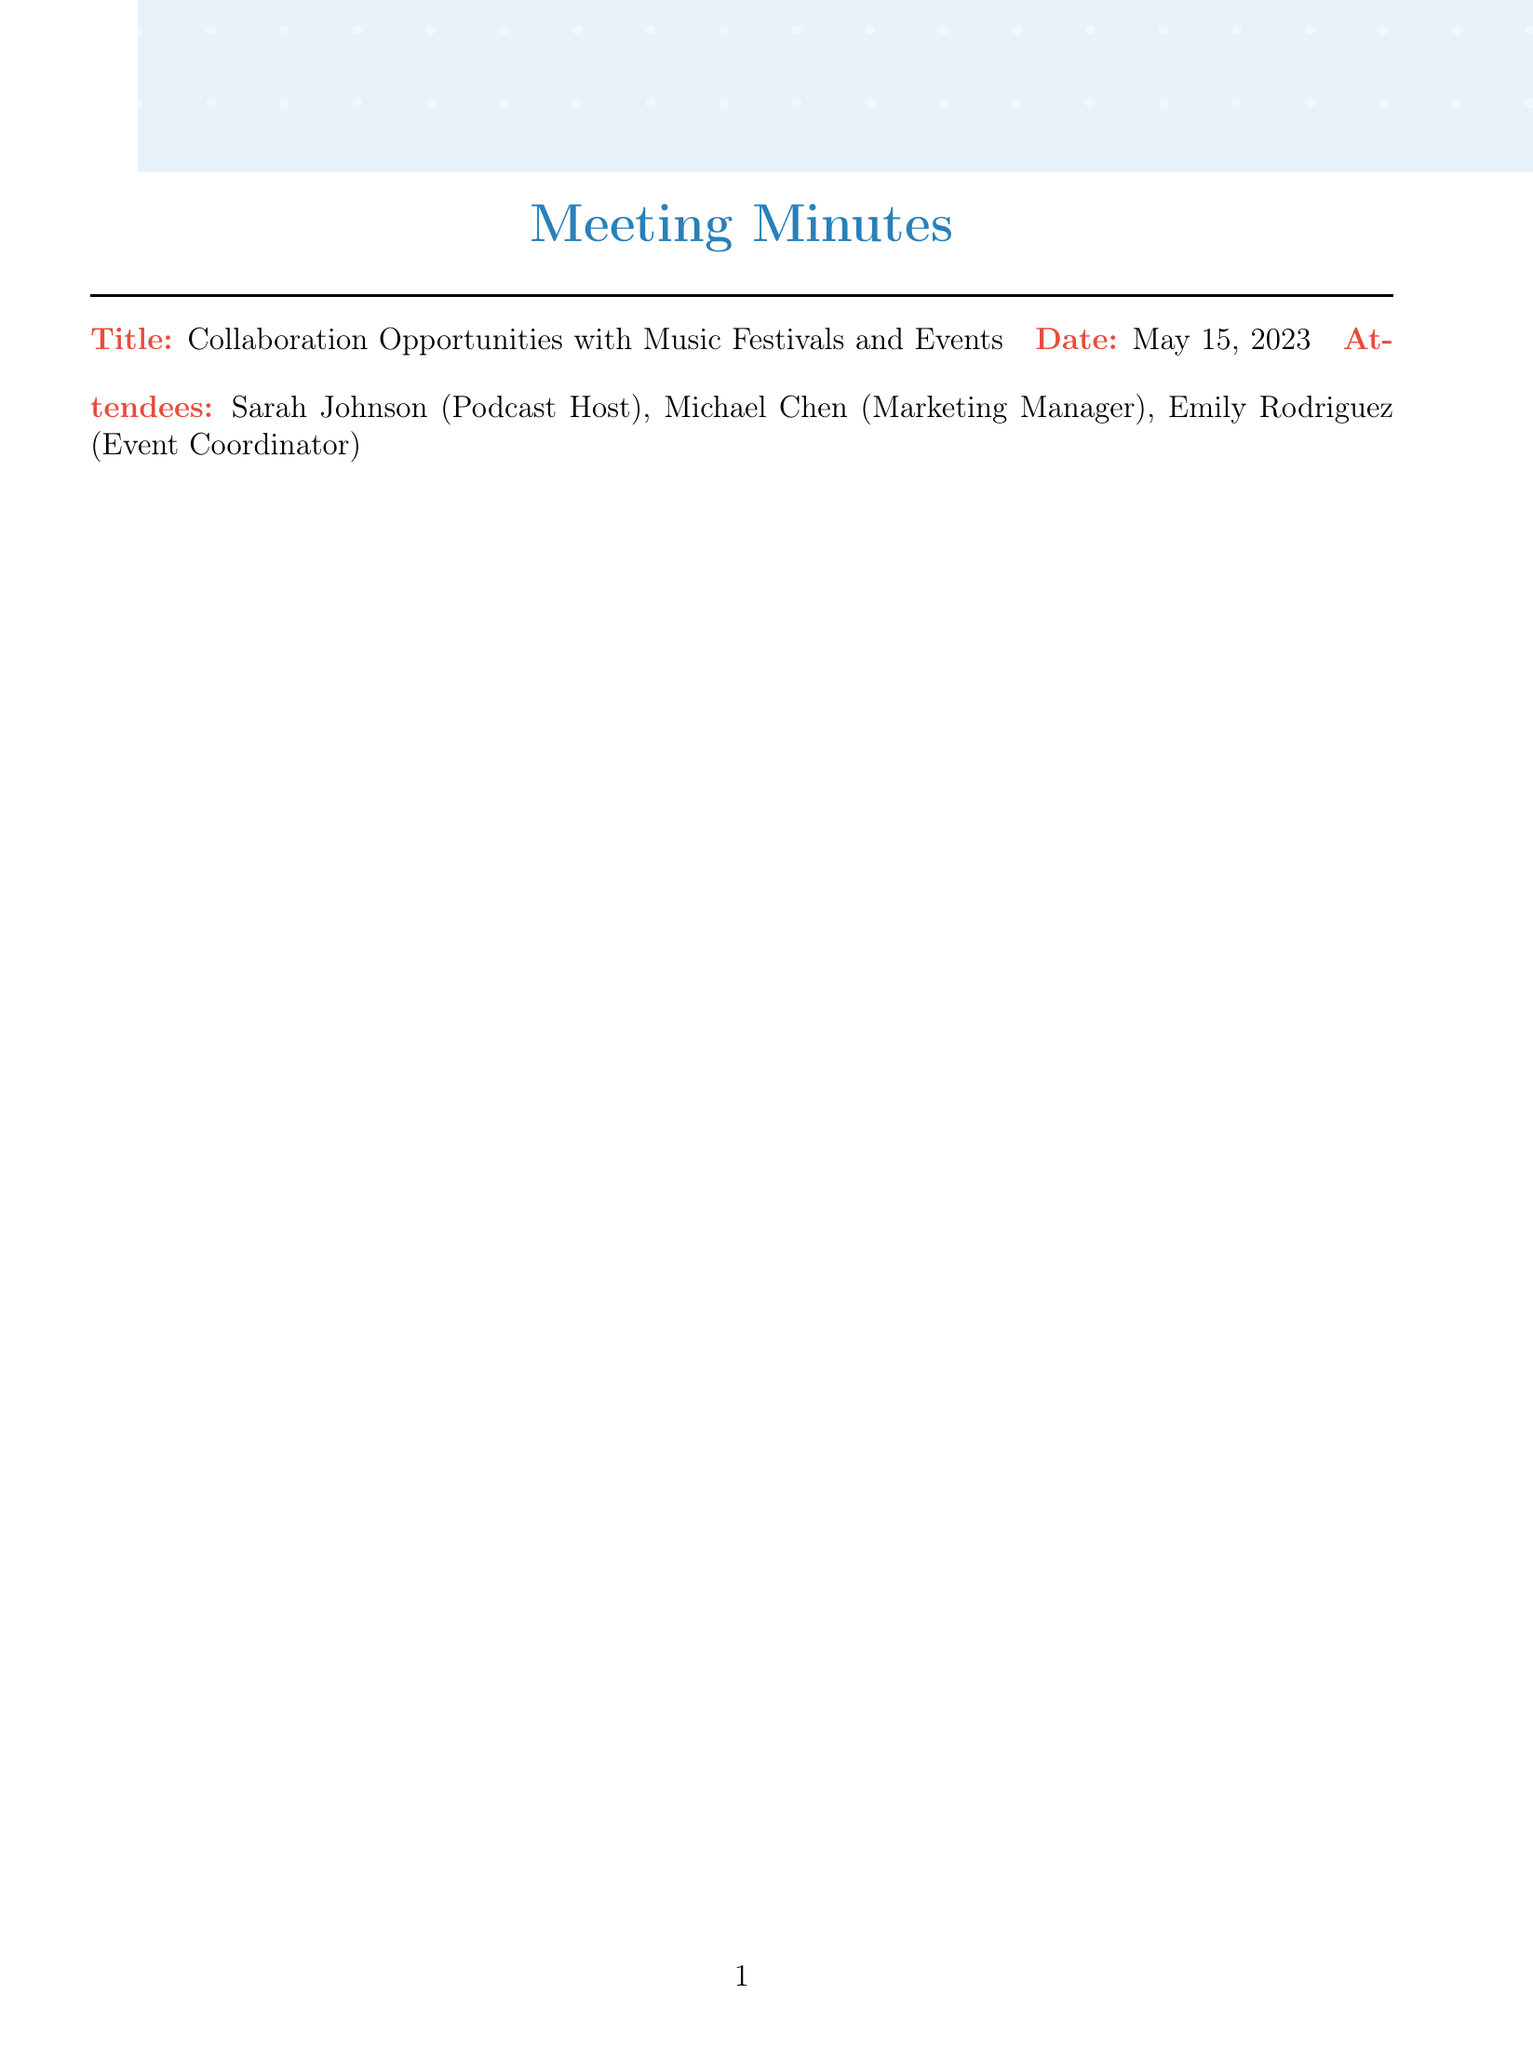What is the date of the meeting? The date of the meeting is stated in the document as May 15, 2023.
Answer: May 15, 2023 Who is the podcast host? The document lists Sarah Johnson as the podcast host among the attendees.
Answer: Sarah Johnson What are the potential festival partnerships? The document outlines several festivals, including Coachella Valley Music and Arts Festival, Bonnaroo Music & Arts Festival, Lollapalooza, and Governor's Ball Music Festival.
Answer: Coachella Valley Music and Arts Festival, Bonnaroo Music & Arts Festival, Lollapalooza, Governor's Ball Music Festival What is one collaboration idea mentioned? Collaboration ideas include hosting live podcast recordings at festival grounds, which is specified in the document.
Answer: Host live podcast recordings at festival grounds Which artist is targeted for interviews? The document lists Ariana Grande, The Weeknd, Taylor Swift, and Bruno Mars as target artists for interviews.
Answer: Ariana Grande How many next steps are listed in the document? There are four next steps mentioned in the document regarding the collaboration opportunities.
Answer: Four What is one promotion strategy listed? The document mentions cross-promoting on festival social media channels as a promotion strategy.
Answer: Cross-promote on festival social media channels What technical requirement is specified for on-site interviews? The document specifies portable recording equipment for on-site interviews as a technical requirement.
Answer: Portable recording equipment 